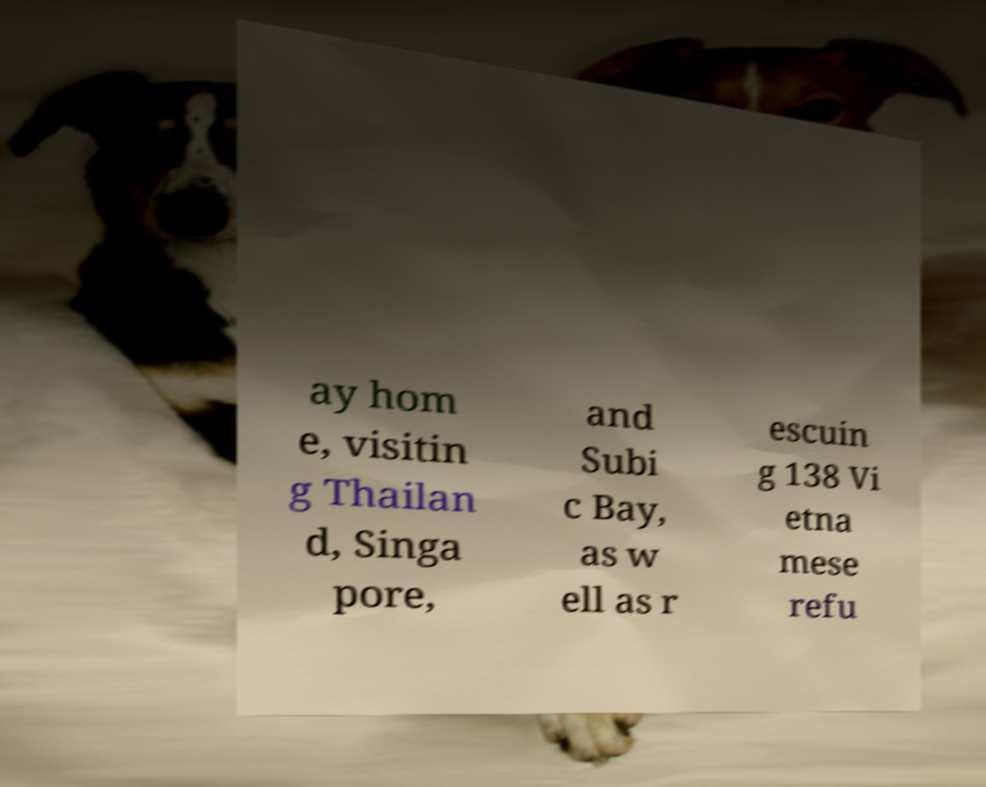Could you assist in decoding the text presented in this image and type it out clearly? ay hom e, visitin g Thailan d, Singa pore, and Subi c Bay, as w ell as r escuin g 138 Vi etna mese refu 